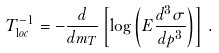Convert formula to latex. <formula><loc_0><loc_0><loc_500><loc_500>T _ { \mathrm l o c } ^ { - 1 } = - \frac { d } { d m _ { T } } \left [ \log \left ( E \frac { d ^ { 3 } \sigma } { d p ^ { 3 } } \right ) \right ] \, .</formula> 